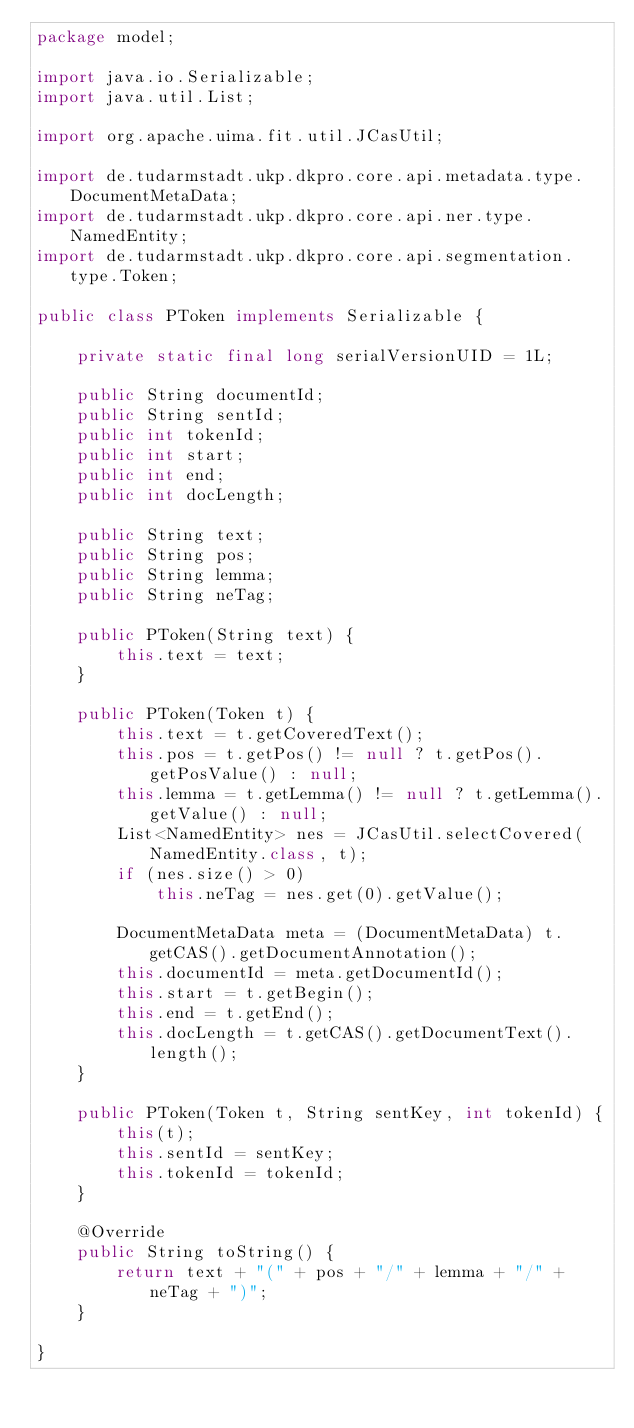<code> <loc_0><loc_0><loc_500><loc_500><_Java_>package model;

import java.io.Serializable;
import java.util.List;

import org.apache.uima.fit.util.JCasUtil;

import de.tudarmstadt.ukp.dkpro.core.api.metadata.type.DocumentMetaData;
import de.tudarmstadt.ukp.dkpro.core.api.ner.type.NamedEntity;
import de.tudarmstadt.ukp.dkpro.core.api.segmentation.type.Token;

public class PToken implements Serializable {

	private static final long serialVersionUID = 1L;

	public String documentId;
	public String sentId;
	public int tokenId;
	public int start;
	public int end;
	public int docLength;

	public String text;
	public String pos;
	public String lemma;
	public String neTag;

	public PToken(String text) {
		this.text = text;
	}

	public PToken(Token t) {
		this.text = t.getCoveredText();
		this.pos = t.getPos() != null ? t.getPos().getPosValue() : null;
		this.lemma = t.getLemma() != null ? t.getLemma().getValue() : null;
		List<NamedEntity> nes = JCasUtil.selectCovered(NamedEntity.class, t);
		if (nes.size() > 0)
			this.neTag = nes.get(0).getValue();

		DocumentMetaData meta = (DocumentMetaData) t.getCAS().getDocumentAnnotation();
		this.documentId = meta.getDocumentId();
		this.start = t.getBegin();
		this.end = t.getEnd();
		this.docLength = t.getCAS().getDocumentText().length();
	}

	public PToken(Token t, String sentKey, int tokenId) {
		this(t);
		this.sentId = sentKey;
		this.tokenId = tokenId;
	}

	@Override
	public String toString() {
		return text + "(" + pos + "/" + lemma + "/" + neTag + ")";
	}

}
</code> 